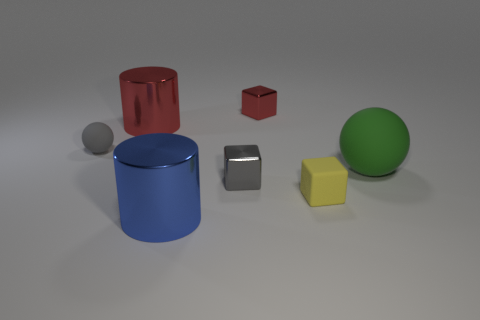There is a large green ball that is in front of the rubber object to the left of the yellow rubber object; what is its material?
Make the answer very short. Rubber. Are there any small metal blocks of the same color as the tiny ball?
Provide a short and direct response. Yes. There is a metallic thing that is the same size as the red shiny cylinder; what is its color?
Offer a terse response. Blue. The gray thing behind the matte sphere that is to the right of the tiny metallic block that is in front of the large red cylinder is made of what material?
Your answer should be compact. Rubber. There is a small sphere; is it the same color as the metallic cube that is in front of the large rubber thing?
Offer a terse response. Yes. How many things are either spheres that are on the right side of the large red metallic cylinder or small metallic cubes in front of the small gray sphere?
Provide a short and direct response. 2. What shape is the small gray thing to the right of the metal object in front of the tiny yellow block?
Your answer should be compact. Cube. Are there any tiny red things that have the same material as the yellow block?
Ensure brevity in your answer.  No. There is another object that is the same shape as the large red metal thing; what color is it?
Provide a short and direct response. Blue. Is the number of red metallic cubes left of the red metallic cube less than the number of small rubber things behind the large green thing?
Provide a short and direct response. Yes. 